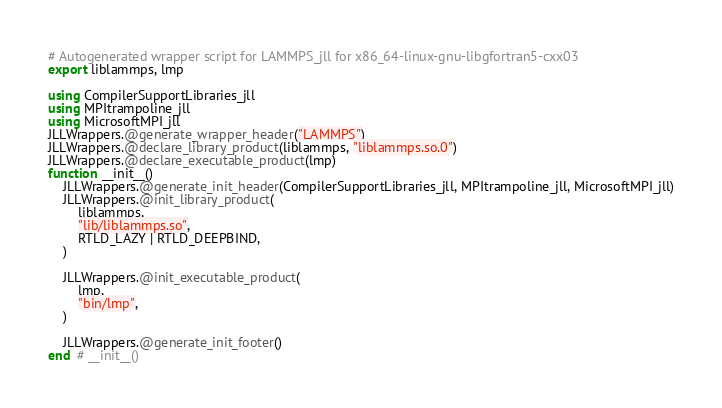<code> <loc_0><loc_0><loc_500><loc_500><_Julia_># Autogenerated wrapper script for LAMMPS_jll for x86_64-linux-gnu-libgfortran5-cxx03
export liblammps, lmp

using CompilerSupportLibraries_jll
using MPItrampoline_jll
using MicrosoftMPI_jll
JLLWrappers.@generate_wrapper_header("LAMMPS")
JLLWrappers.@declare_library_product(liblammps, "liblammps.so.0")
JLLWrappers.@declare_executable_product(lmp)
function __init__()
    JLLWrappers.@generate_init_header(CompilerSupportLibraries_jll, MPItrampoline_jll, MicrosoftMPI_jll)
    JLLWrappers.@init_library_product(
        liblammps,
        "lib/liblammps.so",
        RTLD_LAZY | RTLD_DEEPBIND,
    )

    JLLWrappers.@init_executable_product(
        lmp,
        "bin/lmp",
    )

    JLLWrappers.@generate_init_footer()
end  # __init__()
</code> 